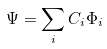Convert formula to latex. <formula><loc_0><loc_0><loc_500><loc_500>\Psi = \sum _ { i } C _ { i } \Phi _ { i }</formula> 